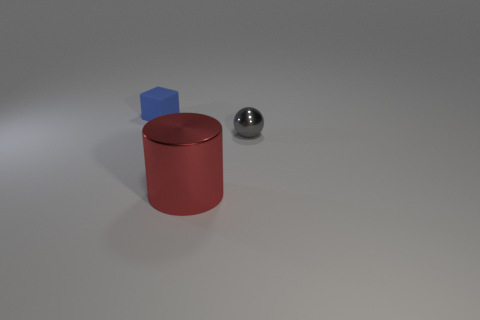What number of other small gray objects are the same shape as the small metallic thing?
Provide a short and direct response. 0. What shape is the small rubber thing?
Keep it short and to the point. Cube. Is the number of tiny blue objects less than the number of tiny objects?
Make the answer very short. Yes. Is there any other thing that has the same size as the cylinder?
Your answer should be compact. No. Is the number of big red cylinders greater than the number of metallic things?
Offer a terse response. No. How many other objects are there of the same color as the ball?
Your answer should be very brief. 0. Is the big object made of the same material as the small thing that is in front of the blue matte block?
Make the answer very short. Yes. There is a large red cylinder on the left side of the small thing on the right side of the blue object; what number of shiny objects are on the right side of it?
Your answer should be compact. 1. Is the number of tiny matte cubes right of the big object less than the number of tiny objects on the left side of the tiny shiny sphere?
Offer a very short reply. Yes. What number of other things are there of the same material as the gray object
Ensure brevity in your answer.  1. 